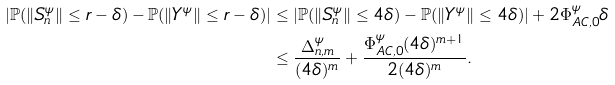Convert formula to latex. <formula><loc_0><loc_0><loc_500><loc_500>| \mathbb { P } ( \| S _ { n } ^ { \psi } \| \leq r - \delta ) - \mathbb { P } ( \| Y ^ { \psi } \| \leq r - \delta ) | & \leq | \mathbb { P } ( \| S _ { n } ^ { \psi } \| \leq 4 \delta ) - \mathbb { P } ( \| Y ^ { \psi } \| \leq 4 \delta ) | + 2 \Phi _ { A C , 0 } ^ { \psi } \delta \\ & \leq \frac { \Delta _ { n , m } ^ { \psi } } { ( 4 \delta ) ^ { m } } + \frac { \Phi _ { A C , 0 } ^ { \psi } ( 4 \delta ) ^ { m + 1 } } { 2 ( 4 \delta ) ^ { m } } .</formula> 